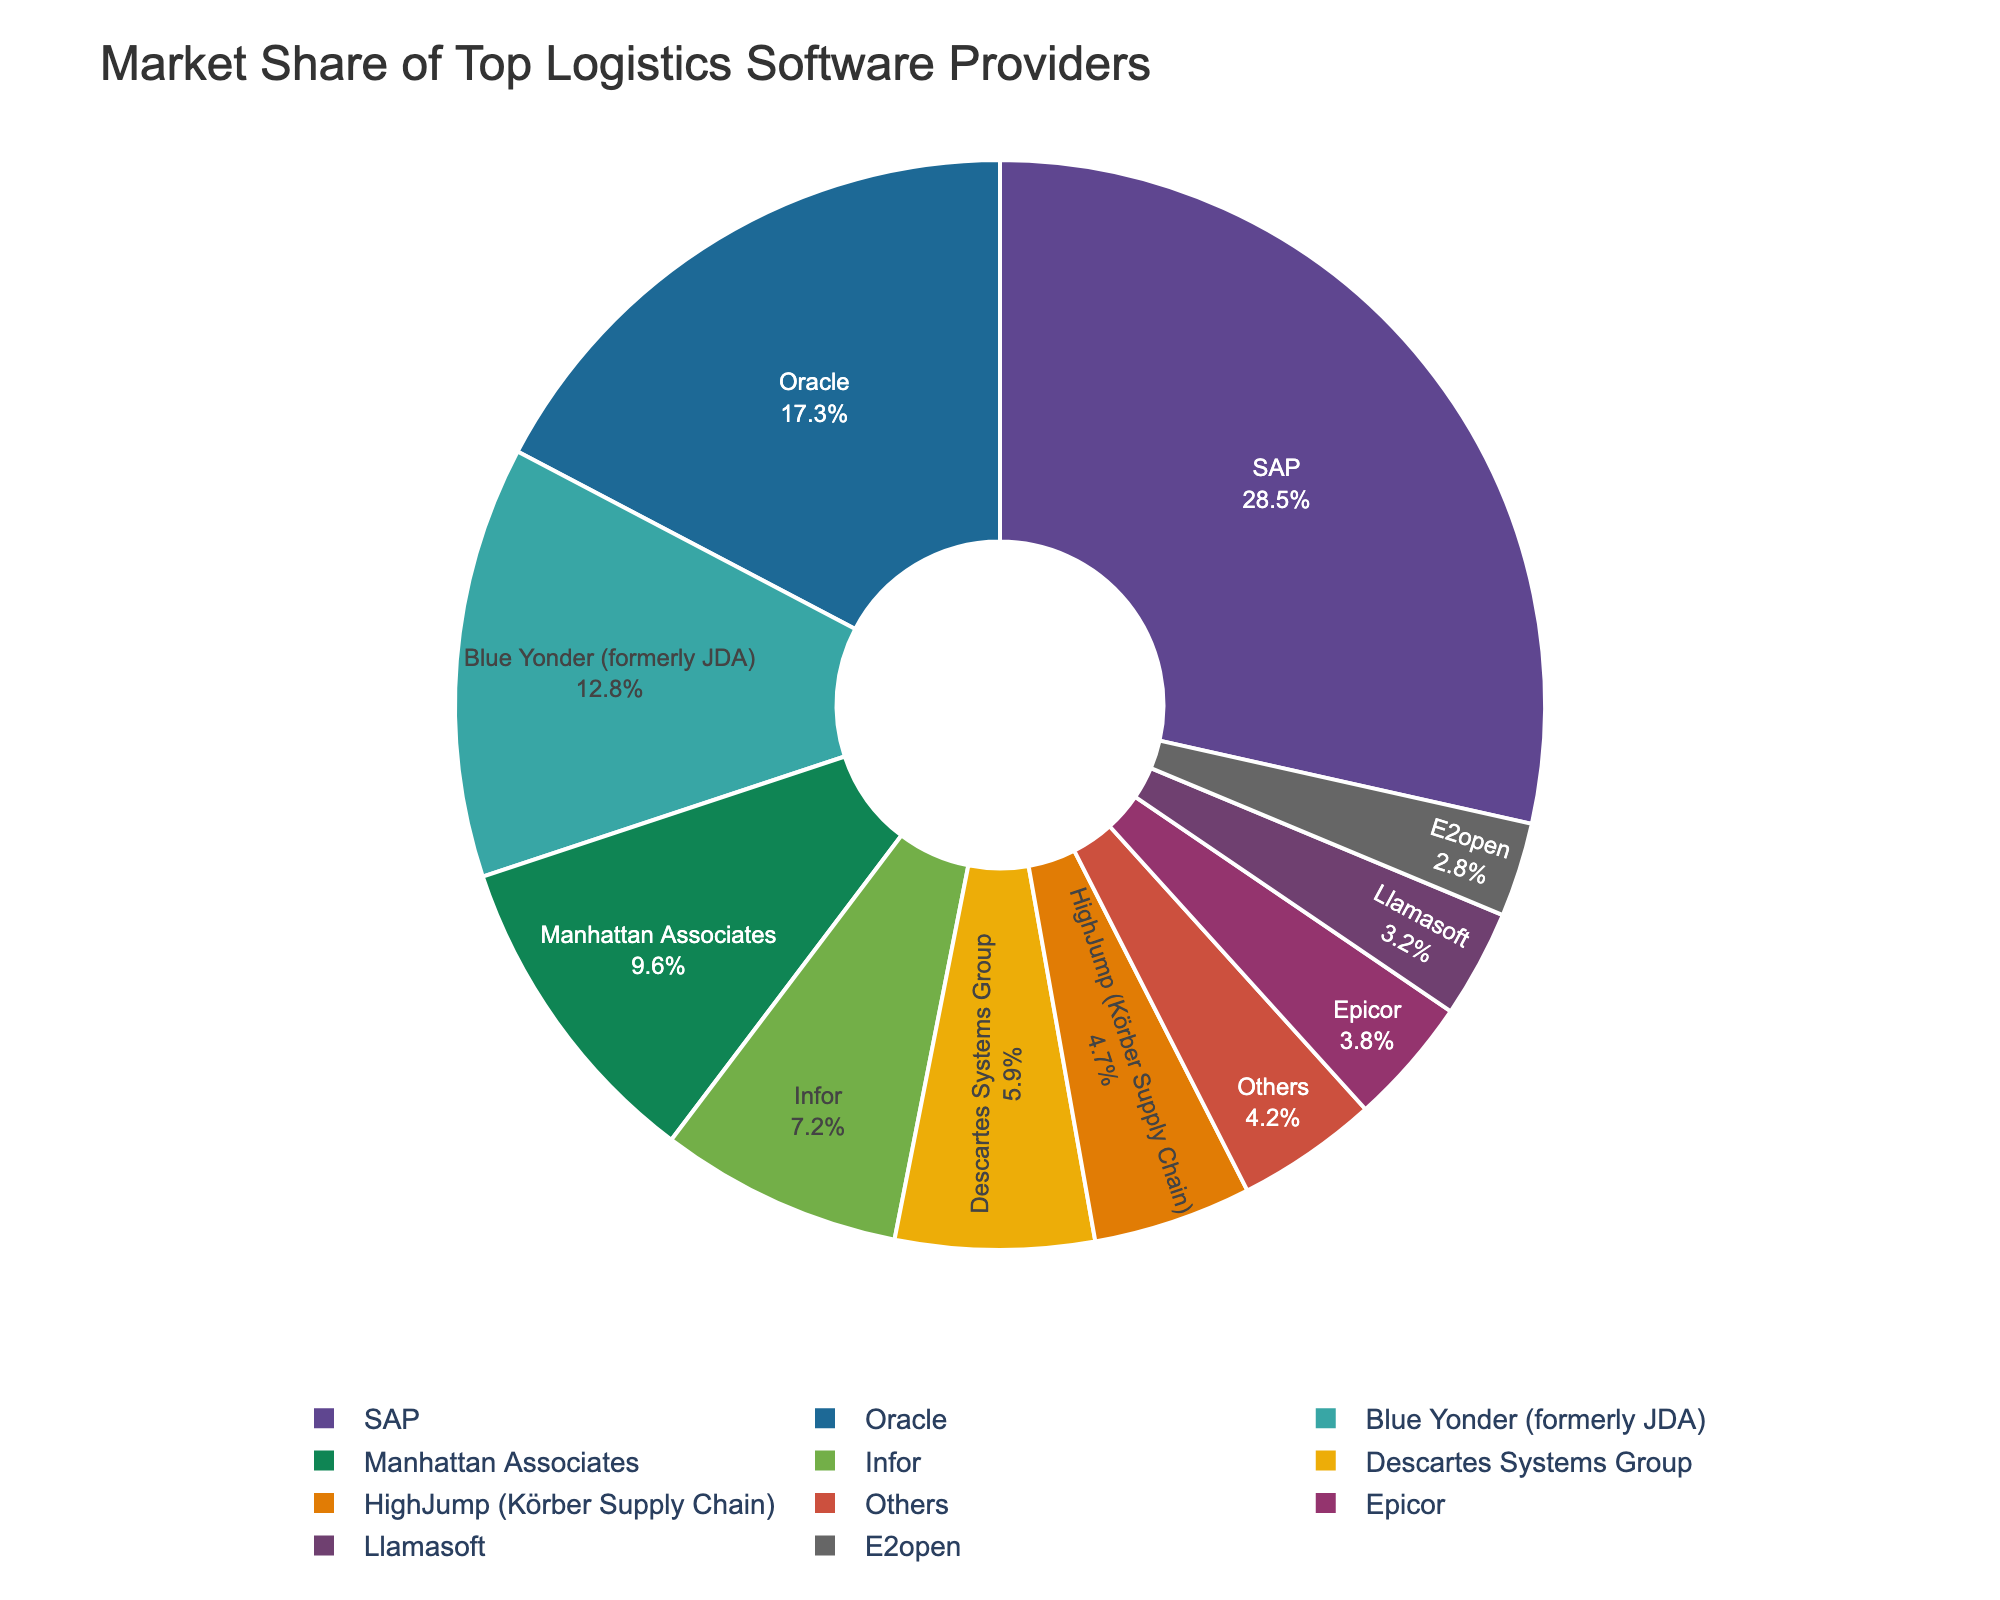Which logistics software provider has the largest market share? The pie chart clearly shows the sizes of market shares represented as slices. By observing the chart, the largest slice belongs to SAP.
Answer: SAP What is the combined market share of Oracle and Infor? To find the combined market share, add the individual market shares of Oracle (17.3%) and Infor (7.2%). This equals 17.3% + 7.2% = 24.5%.
Answer: 24.5% Who holds a larger market share, Descartes Systems Group or HighJump (Körber Supply Chain)? By observing the pie chart, Descartes Systems Group holds 5.9% and HighJump (Körber Supply Chain) holds 4.7%. Therefore, Descartes Systems Group has a larger market share.
Answer: Descartes Systems Group What is the difference in market share between SAP and Manhattan Associates? The market share for SAP is 28.5% and for Manhattan Associates is 9.6%. Subtract Manhattan Associates' share from SAP's share: 28.5% - 9.6% = 18.9%.
Answer: 18.9% Is the total market share of all providers other than SAP greater than 60%? Add all market shares except for SAP: Oracle (17.3%) + Blue Yonder (12.8%) + Manhattan Associates (9.6%) + Infor (7.2%) + Descartes Systems Group (5.9%) + HighJump (4.7%) + Epicor (3.8%) + Llamasoft (3.2%) + E2open (2.8%) + Others (4.2%). This equals 71.5%. Since 71.5% > 60%, the total market share of all other providers is indeed greater than 60%.
Answer: Yes Which software provider has a market share closest to 10%? By observing the chart, Manhattan Associates has a market share of 9.6%, which is closest to 10%.
Answer: Manhattan Associates How much larger is SAP's market share compared to the combined market share of Blue Yonder and Epicor? First, calculate the combined market share of Blue Yonder (12.8%) and Epicor (3.8%). This equals 12.8% + 3.8% = 16.6%. Then, subtract this from SAP's share: 28.5% - 16.6% = 11.9%.
Answer: 11.9% Which providers have market shares less than 5%? Observing the slices, the providers with market shares less than 5% are HighJump (4.7%), Epicor (3.8%), Llamasoft (3.2%), and E2open (2.8%).
Answer: HighJump, Epicor, Llamasoft, E2open 